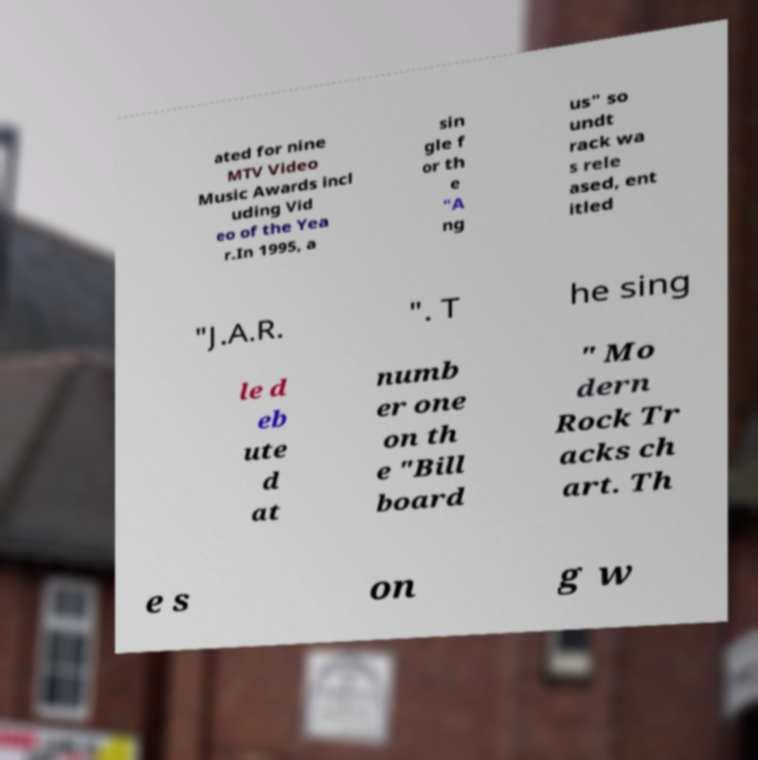For documentation purposes, I need the text within this image transcribed. Could you provide that? ated for nine MTV Video Music Awards incl uding Vid eo of the Yea r.In 1995, a sin gle f or th e "A ng us" so undt rack wa s rele ased, ent itled "J.A.R. ". T he sing le d eb ute d at numb er one on th e "Bill board " Mo dern Rock Tr acks ch art. Th e s on g w 